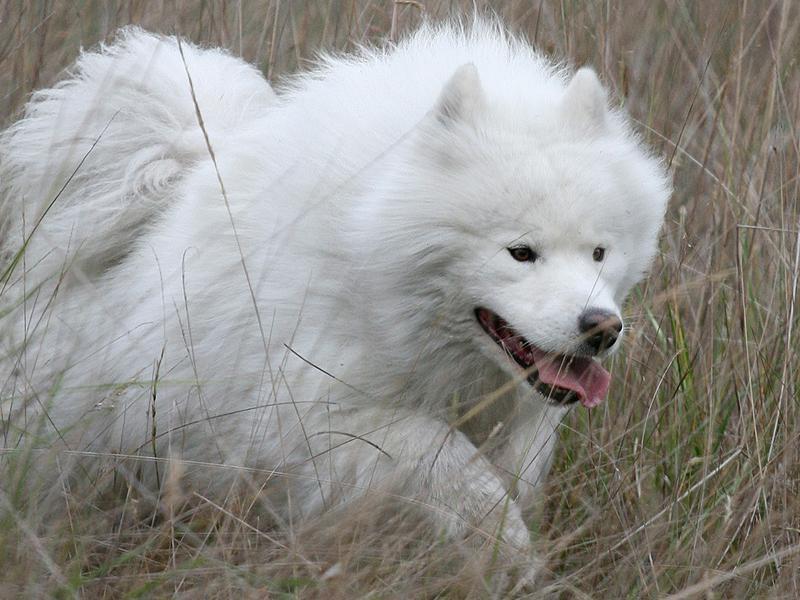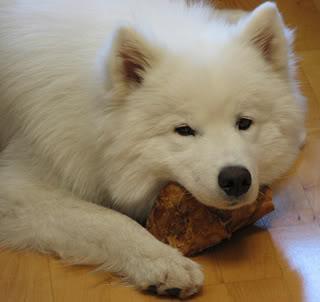The first image is the image on the left, the second image is the image on the right. Assess this claim about the two images: "Both white dogs have their tongues hanging out of their mouths.". Correct or not? Answer yes or no. No. 